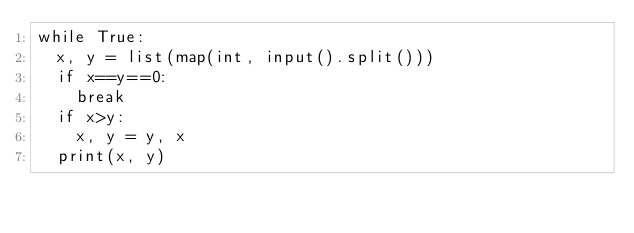<code> <loc_0><loc_0><loc_500><loc_500><_Python_>while True:
  x, y = list(map(int, input().split()))
  if x==y==0:
    break
  if x>y:
    x, y = y, x
  print(x, y)
</code> 